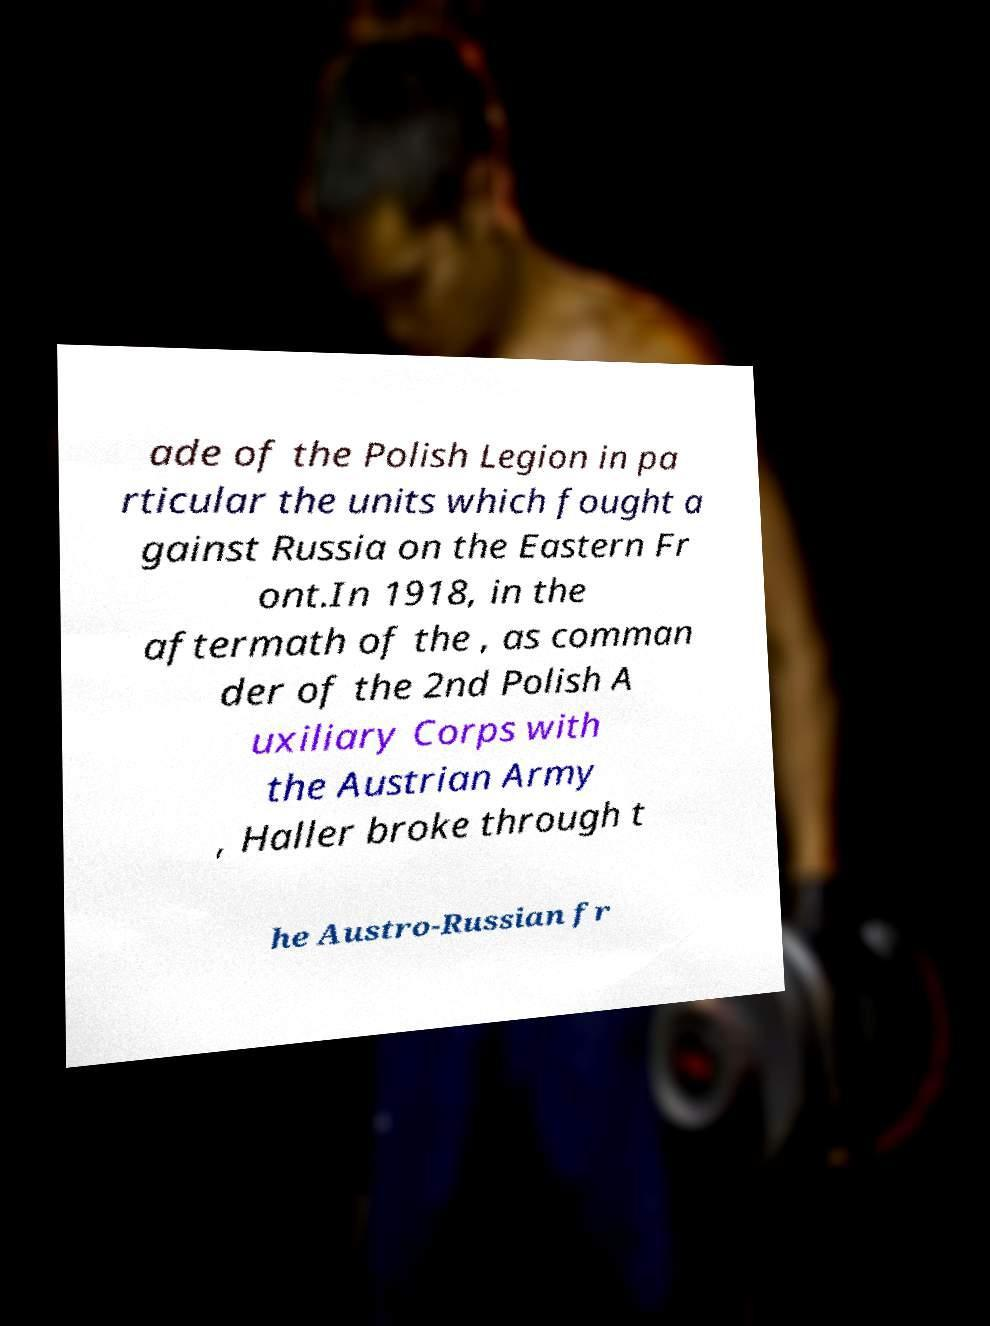Could you assist in decoding the text presented in this image and type it out clearly? ade of the Polish Legion in pa rticular the units which fought a gainst Russia on the Eastern Fr ont.In 1918, in the aftermath of the , as comman der of the 2nd Polish A uxiliary Corps with the Austrian Army , Haller broke through t he Austro-Russian fr 